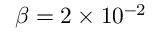<formula> <loc_0><loc_0><loc_500><loc_500>\beta = 2 \times 1 0 ^ { - 2 }</formula> 